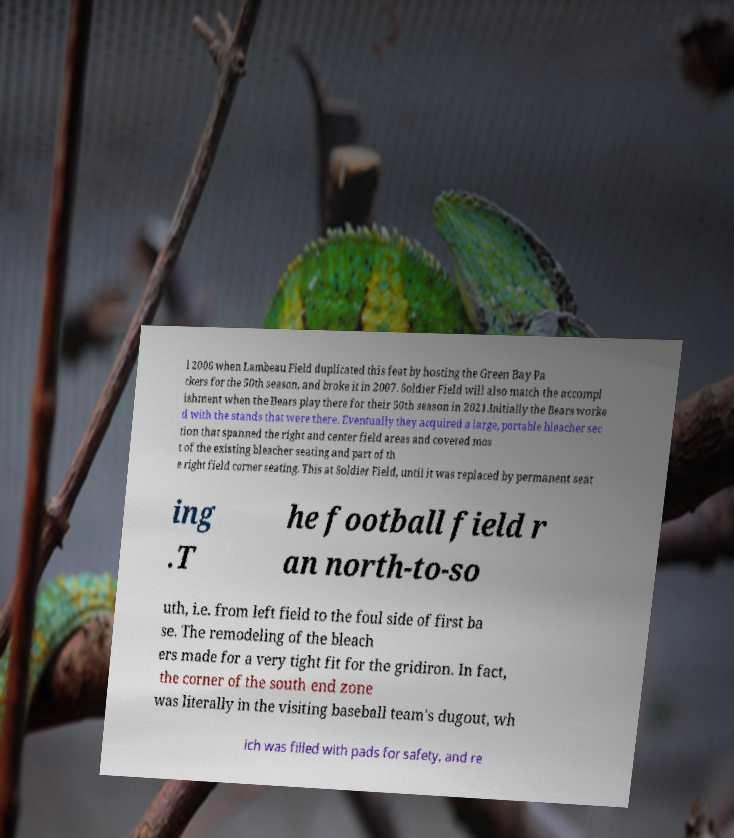Could you assist in decoding the text presented in this image and type it out clearly? l 2006 when Lambeau Field duplicated this feat by hosting the Green Bay Pa ckers for the 50th season, and broke it in 2007. Soldier Field will also match the accompl ishment when the Bears play there for their 50th season in 2021.Initially the Bears worke d with the stands that were there. Eventually they acquired a large, portable bleacher sec tion that spanned the right and center field areas and covered mos t of the existing bleacher seating and part of th e right field corner seating. This at Soldier Field, until it was replaced by permanent seat ing .T he football field r an north-to-so uth, i.e. from left field to the foul side of first ba se. The remodeling of the bleach ers made for a very tight fit for the gridiron. In fact, the corner of the south end zone was literally in the visiting baseball team's dugout, wh ich was filled with pads for safety, and re 